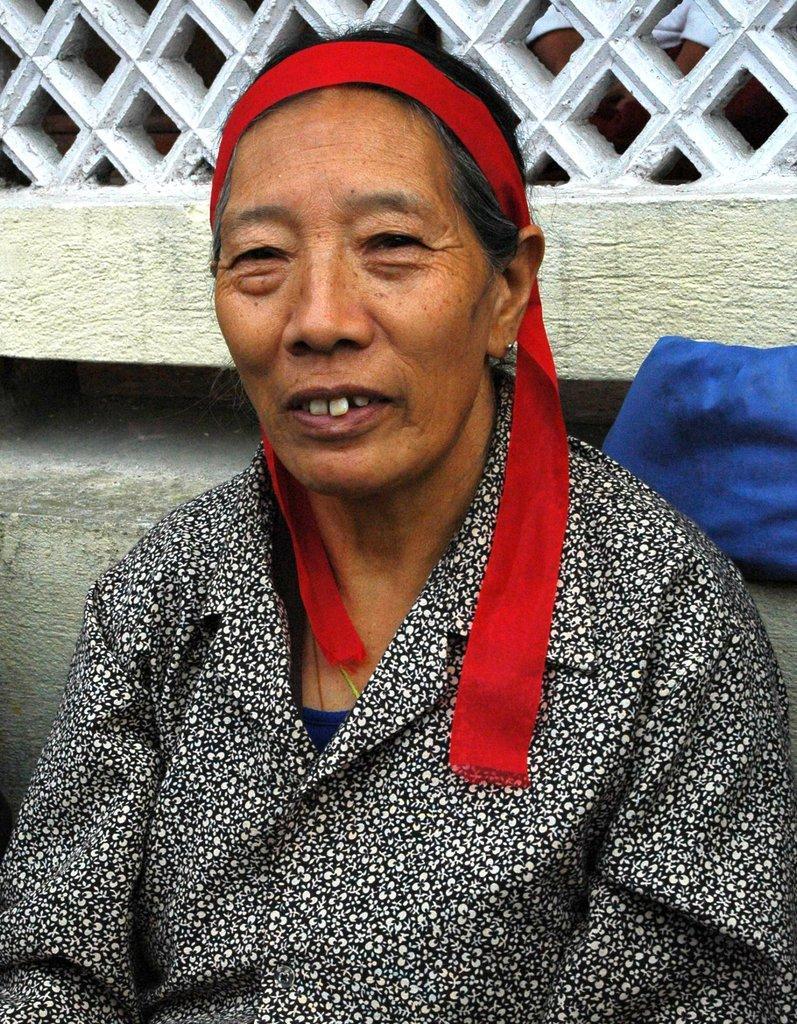In one or two sentences, can you explain what this image depicts? In the center of the image we can see a woman sitting. She is wearing a black shirt. In the background there is a wall. 